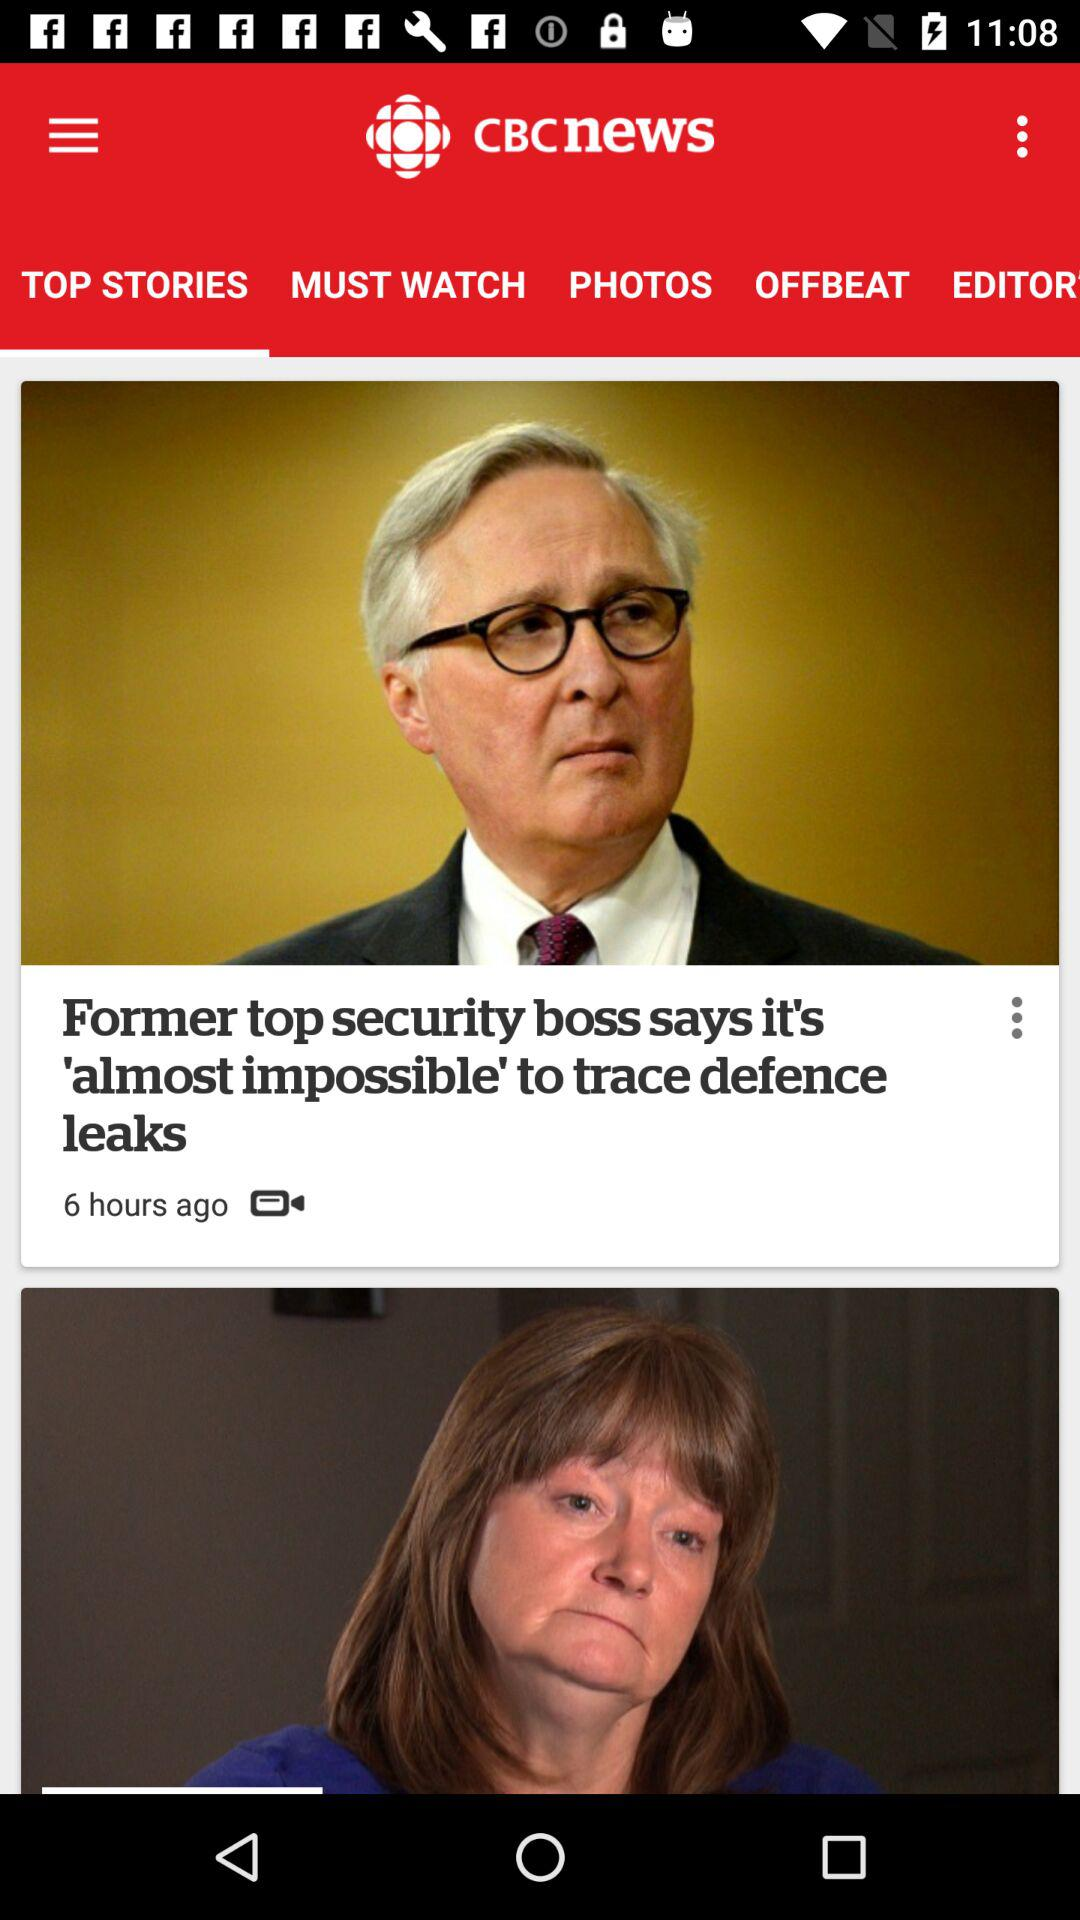Which tab is selected? The selected tab is "TOP STORIES". 